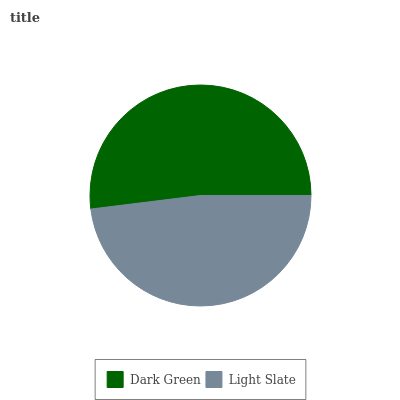Is Light Slate the minimum?
Answer yes or no. Yes. Is Dark Green the maximum?
Answer yes or no. Yes. Is Light Slate the maximum?
Answer yes or no. No. Is Dark Green greater than Light Slate?
Answer yes or no. Yes. Is Light Slate less than Dark Green?
Answer yes or no. Yes. Is Light Slate greater than Dark Green?
Answer yes or no. No. Is Dark Green less than Light Slate?
Answer yes or no. No. Is Dark Green the high median?
Answer yes or no. Yes. Is Light Slate the low median?
Answer yes or no. Yes. Is Light Slate the high median?
Answer yes or no. No. Is Dark Green the low median?
Answer yes or no. No. 